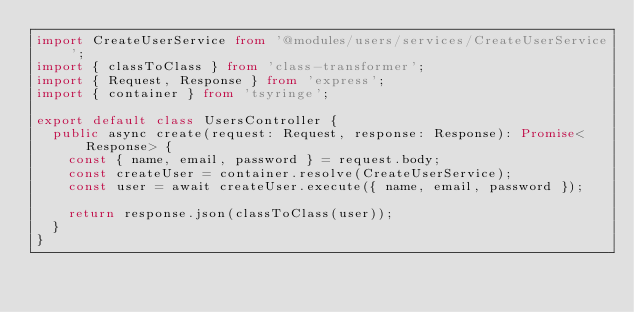Convert code to text. <code><loc_0><loc_0><loc_500><loc_500><_TypeScript_>import CreateUserService from '@modules/users/services/CreateUserService';
import { classToClass } from 'class-transformer';
import { Request, Response } from 'express';
import { container } from 'tsyringe';

export default class UsersController {
  public async create(request: Request, response: Response): Promise<Response> {
    const { name, email, password } = request.body;
    const createUser = container.resolve(CreateUserService);
    const user = await createUser.execute({ name, email, password });

    return response.json(classToClass(user));
  }
}
</code> 